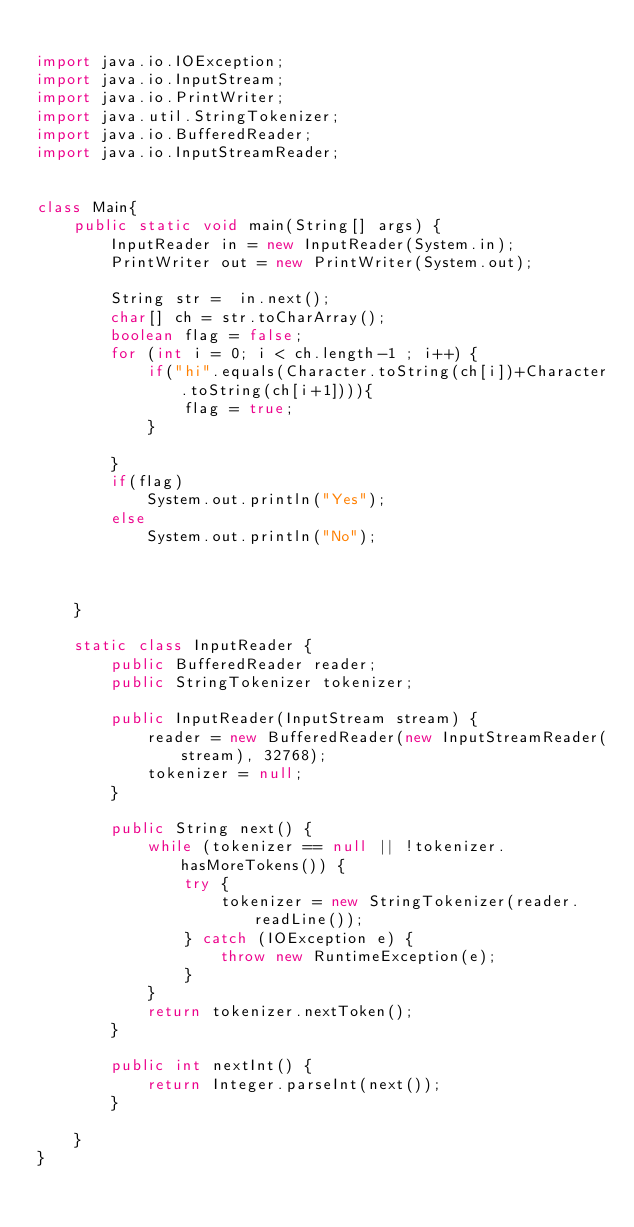Convert code to text. <code><loc_0><loc_0><loc_500><loc_500><_Java_>
import java.io.IOException;
import java.io.InputStream;
import java.io.PrintWriter;
import java.util.StringTokenizer;
import java.io.BufferedReader;
import java.io.InputStreamReader;


class Main{
    public static void main(String[] args) {
        InputReader in = new InputReader(System.in);
        PrintWriter out = new PrintWriter(System.out);

        String str =  in.next();
        char[] ch = str.toCharArray();
        boolean flag = false;
        for (int i = 0; i < ch.length-1 ; i++) {
            if("hi".equals(Character.toString(ch[i])+Character.toString(ch[i+1]))){
                flag = true;
            }

        }
        if(flag)
            System.out.println("Yes");
        else
            System.out.println("No");



    }

    static class InputReader {
        public BufferedReader reader;
        public StringTokenizer tokenizer;

        public InputReader(InputStream stream) {
            reader = new BufferedReader(new InputStreamReader(stream), 32768);
            tokenizer = null;
        }

        public String next() {
            while (tokenizer == null || !tokenizer.hasMoreTokens()) {
                try {
                    tokenizer = new StringTokenizer(reader.readLine());
                } catch (IOException e) {
                    throw new RuntimeException(e);
                }
            }
            return tokenizer.nextToken();
        }

        public int nextInt() {
            return Integer.parseInt(next());
        }

    }
}
</code> 